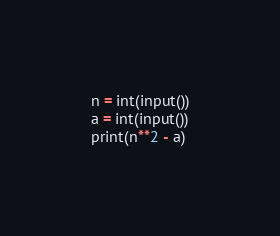<code> <loc_0><loc_0><loc_500><loc_500><_Python_>n = int(input())
a = int(input())
print(n**2 - a)
</code> 